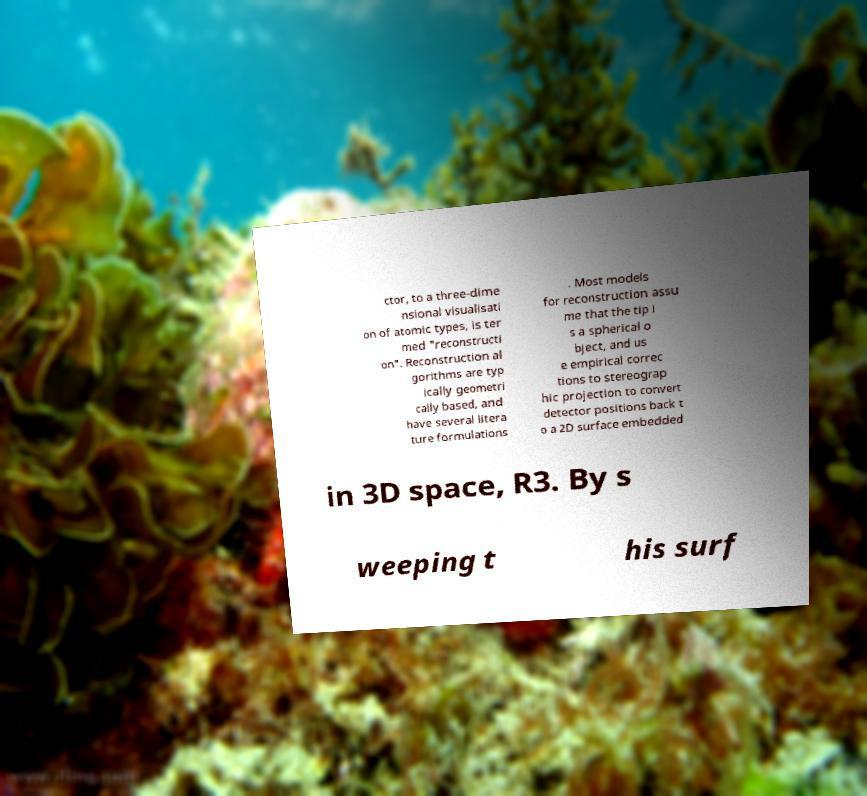There's text embedded in this image that I need extracted. Can you transcribe it verbatim? ctor, to a three-dime nsional visualisati on of atomic types, is ter med "reconstructi on". Reconstruction al gorithms are typ ically geometri cally based, and have several litera ture formulations . Most models for reconstruction assu me that the tip i s a spherical o bject, and us e empirical correc tions to stereograp hic projection to convert detector positions back t o a 2D surface embedded in 3D space, R3. By s weeping t his surf 